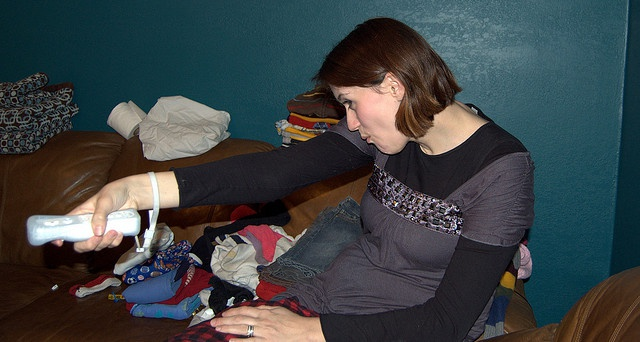Describe the objects in this image and their specific colors. I can see people in black, gray, and tan tones, couch in black, maroon, and gray tones, couch in black, gray, and purple tones, couch in black, maroon, and brown tones, and remote in black, white, darkgray, and lightblue tones in this image. 